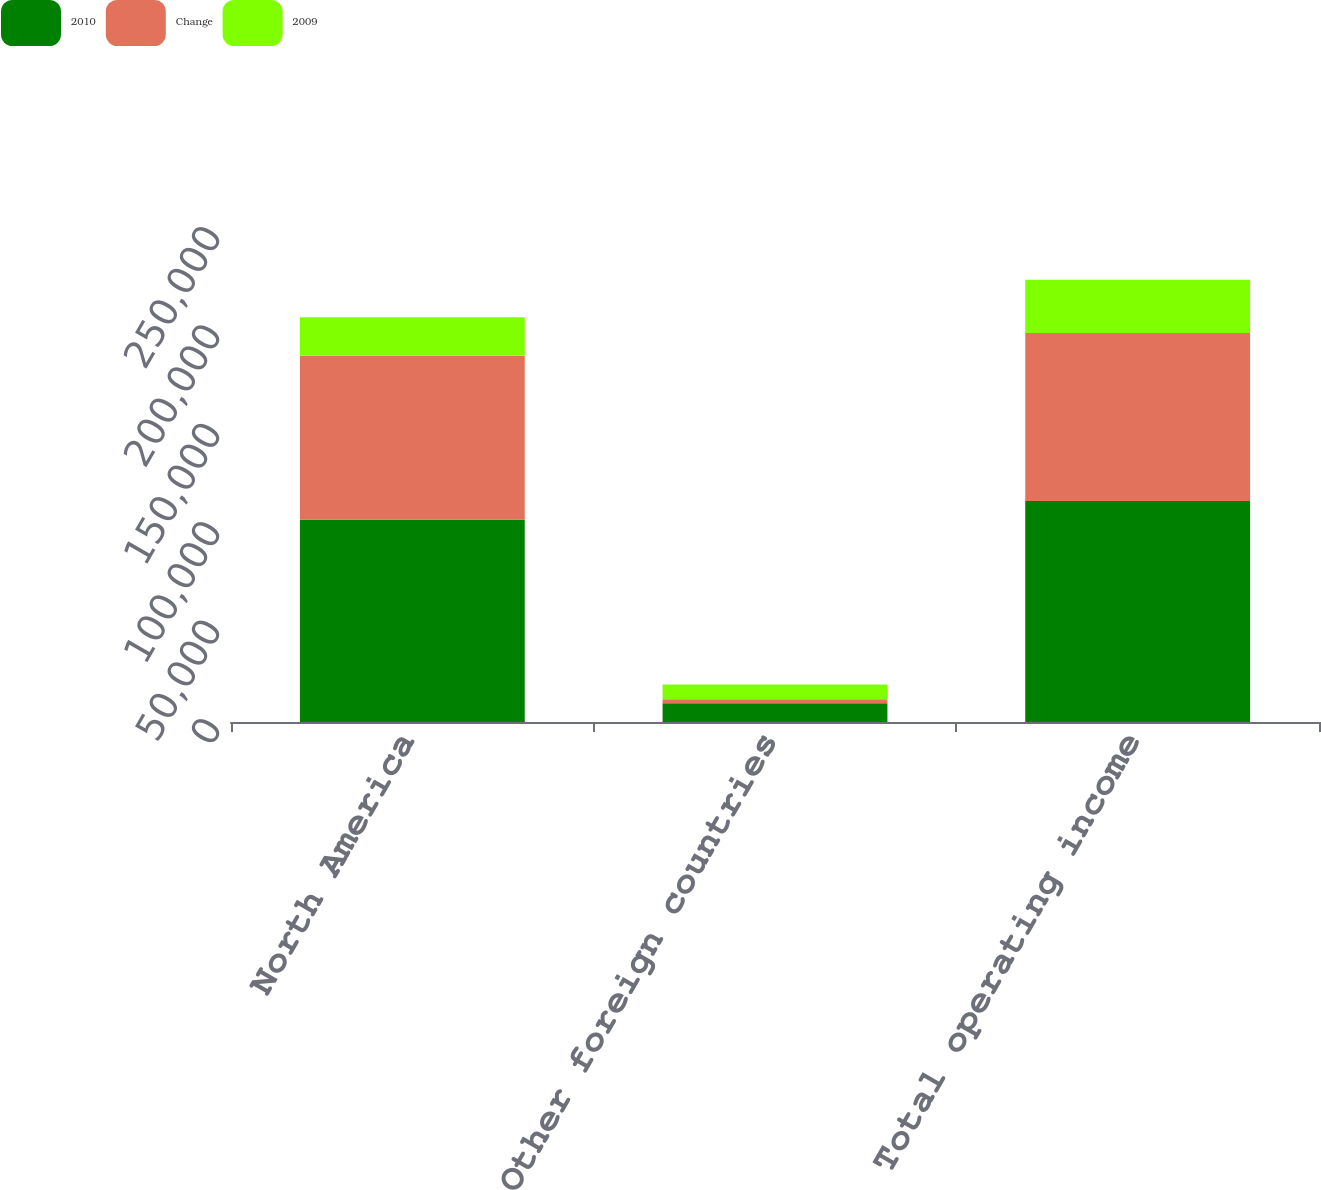Convert chart to OTSL. <chart><loc_0><loc_0><loc_500><loc_500><stacked_bar_chart><ecel><fcel>North America<fcel>Other foreign countries<fcel>Total operating income<nl><fcel>2010<fcel>102806<fcel>9549<fcel>112355<nl><fcel>Change<fcel>83239<fcel>2034<fcel>85273<nl><fcel>2009<fcel>19567<fcel>7515<fcel>27082<nl></chart> 